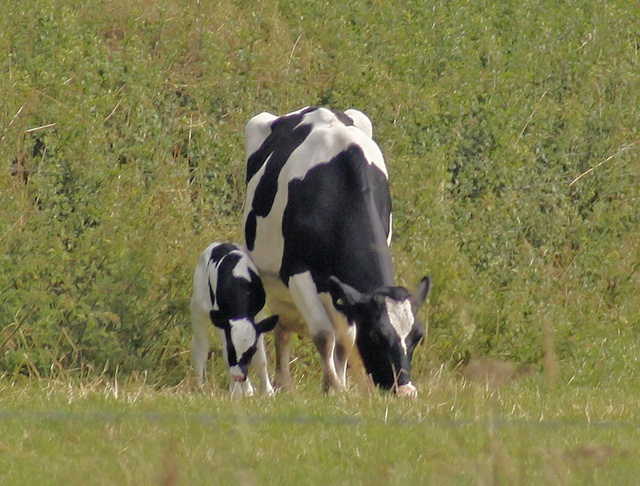Describe the objects in this image and their specific colors. I can see cow in olive, black, gray, and darkgray tones and cow in olive, black, darkgray, and gray tones in this image. 